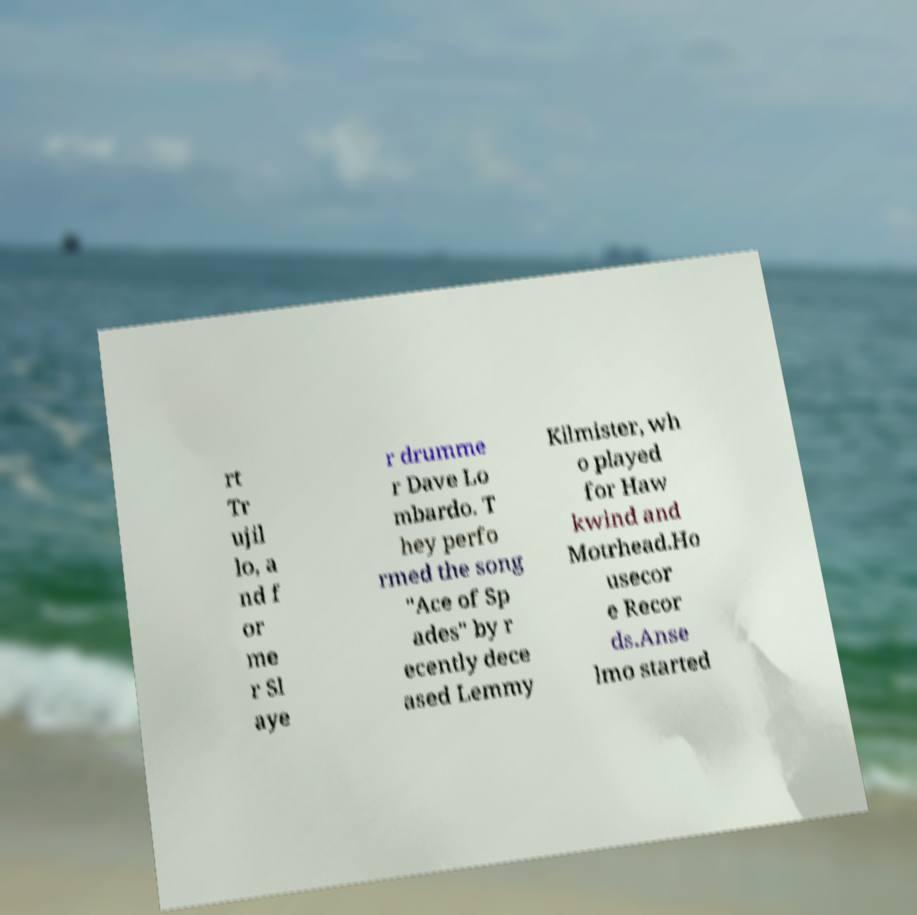Could you extract and type out the text from this image? rt Tr ujil lo, a nd f or me r Sl aye r drumme r Dave Lo mbardo. T hey perfo rmed the song "Ace of Sp ades" by r ecently dece ased Lemmy Kilmister, wh o played for Haw kwind and Motrhead.Ho usecor e Recor ds.Anse lmo started 